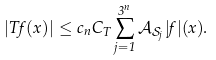<formula> <loc_0><loc_0><loc_500><loc_500>| T f ( x ) | \leq c _ { n } C _ { T } \sum _ { j = 1 } ^ { 3 ^ { n } } { \mathcal { A } } _ { \mathcal { S } _ { j } } | f | ( x ) .</formula> 